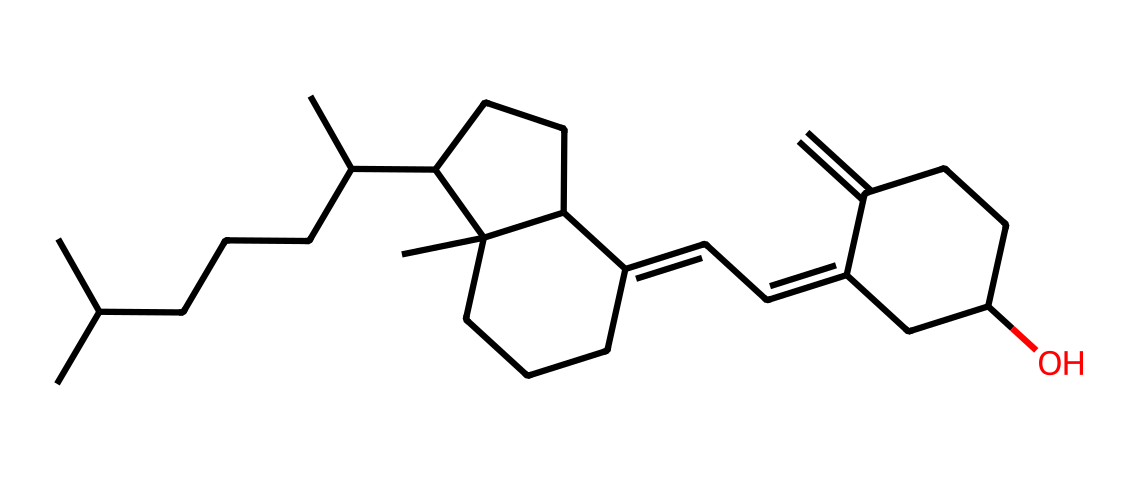How many chiral centers are present in this compound? A chiral center is typically defined as a carbon atom that is bonded to four different substituents. By examining the SMILES representation, we can identify the carbon atoms and determine which ones have four different groups attached. In this structure, there are two carbon atoms that fit this criterion, confirming the presence of two chiral centers.
Answer: two What is the molecular formula of this compound? To derive the molecular formula from the SMILES representation, all carbon (C), hydrogen (H), and oxygen (O) atoms need to be counted. The structure contains 27 carbon atoms, 46 hydrogen atoms, and 1 oxygen atom. Thus, the molecular formula is created by combining these counts.
Answer: C27H46O What type of compound is this, based on its structure? The compound is classified as a steroid. This is identified by the presence of a multi-ring structure typical of steroids. The overall arrangement of carbon atoms in fused rings visually indicates its steroid nature.
Answer: steroid Does this compound have any double bonds? Double bonds can be identified by checking for "C=C" in the SMILES notation. In this chemical, several instances of double bonds are present, indicating that it contains unsaturated carbon chains.
Answer: yes What role does this compound play in natural immunity? This compound is known as vitamin D, which plays a crucial role in enhancing the immune response and maintaining the health of various immune cells. Its function serves as a key component in natural immunity, facilitating the body's defense against pathogens.
Answer: vitamin D How many rings are present in the molecular structure? The rings in a structural formula can be counted by visually identifying and maintaining a tally of closed loops formed by carbon atoms. In the rendered structure from the SMILES, there are three distinct rings present.
Answer: three What is the stereochemistry of the chiral centers in this compound? The stereochemistry of chiral centers can be determined based on the spatial arrangement of the substituents attached to those carbons. In this case, without additional data like R/S notation specified in the structure, we can note that the chiral centers contribute to optical isomerism, making the compound capable of existing in two enantiomeric forms.
Answer: enantiomers 